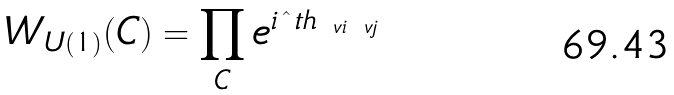<formula> <loc_0><loc_0><loc_500><loc_500>W _ { U ( 1 ) } ( C ) = \prod _ { C } e ^ { i \hat { \ } t h _ { \ v i \ v j } }</formula> 